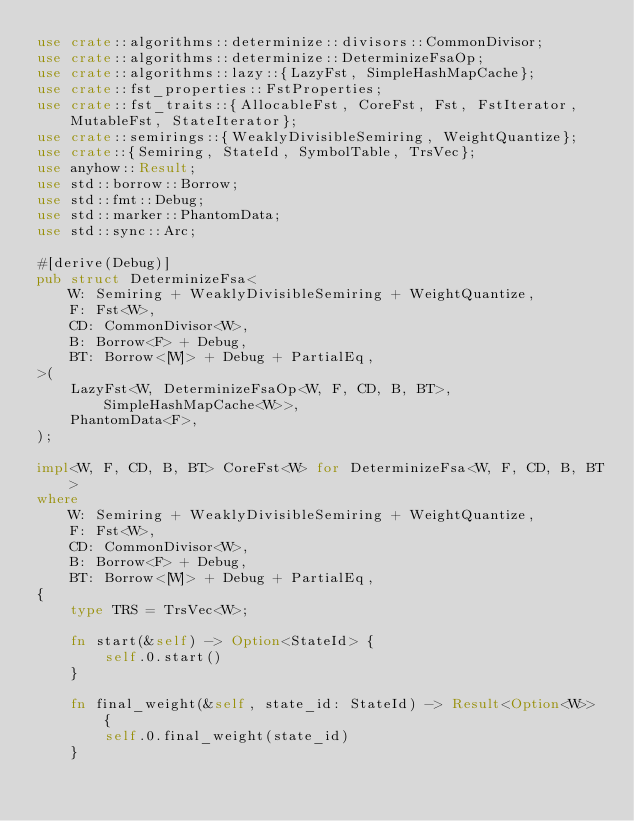Convert code to text. <code><loc_0><loc_0><loc_500><loc_500><_Rust_>use crate::algorithms::determinize::divisors::CommonDivisor;
use crate::algorithms::determinize::DeterminizeFsaOp;
use crate::algorithms::lazy::{LazyFst, SimpleHashMapCache};
use crate::fst_properties::FstProperties;
use crate::fst_traits::{AllocableFst, CoreFst, Fst, FstIterator, MutableFst, StateIterator};
use crate::semirings::{WeaklyDivisibleSemiring, WeightQuantize};
use crate::{Semiring, StateId, SymbolTable, TrsVec};
use anyhow::Result;
use std::borrow::Borrow;
use std::fmt::Debug;
use std::marker::PhantomData;
use std::sync::Arc;

#[derive(Debug)]
pub struct DeterminizeFsa<
    W: Semiring + WeaklyDivisibleSemiring + WeightQuantize,
    F: Fst<W>,
    CD: CommonDivisor<W>,
    B: Borrow<F> + Debug,
    BT: Borrow<[W]> + Debug + PartialEq,
>(
    LazyFst<W, DeterminizeFsaOp<W, F, CD, B, BT>, SimpleHashMapCache<W>>,
    PhantomData<F>,
);

impl<W, F, CD, B, BT> CoreFst<W> for DeterminizeFsa<W, F, CD, B, BT>
where
    W: Semiring + WeaklyDivisibleSemiring + WeightQuantize,
    F: Fst<W>,
    CD: CommonDivisor<W>,
    B: Borrow<F> + Debug,
    BT: Borrow<[W]> + Debug + PartialEq,
{
    type TRS = TrsVec<W>;

    fn start(&self) -> Option<StateId> {
        self.0.start()
    }

    fn final_weight(&self, state_id: StateId) -> Result<Option<W>> {
        self.0.final_weight(state_id)
    }
</code> 